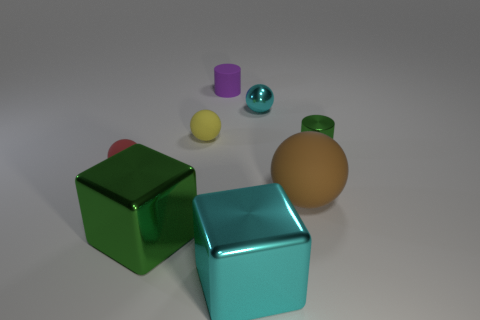Subtract all yellow spheres. How many spheres are left? 3 Subtract 2 cylinders. How many cylinders are left? 0 Subtract all cyan blocks. Subtract all yellow cylinders. How many blocks are left? 1 Subtract all cyan balls. How many green cubes are left? 1 Subtract all big brown rubber objects. Subtract all metal blocks. How many objects are left? 5 Add 6 spheres. How many spheres are left? 10 Add 2 small yellow rubber things. How many small yellow rubber things exist? 3 Add 1 metal spheres. How many objects exist? 9 Subtract all brown spheres. How many spheres are left? 3 Subtract 0 green spheres. How many objects are left? 8 